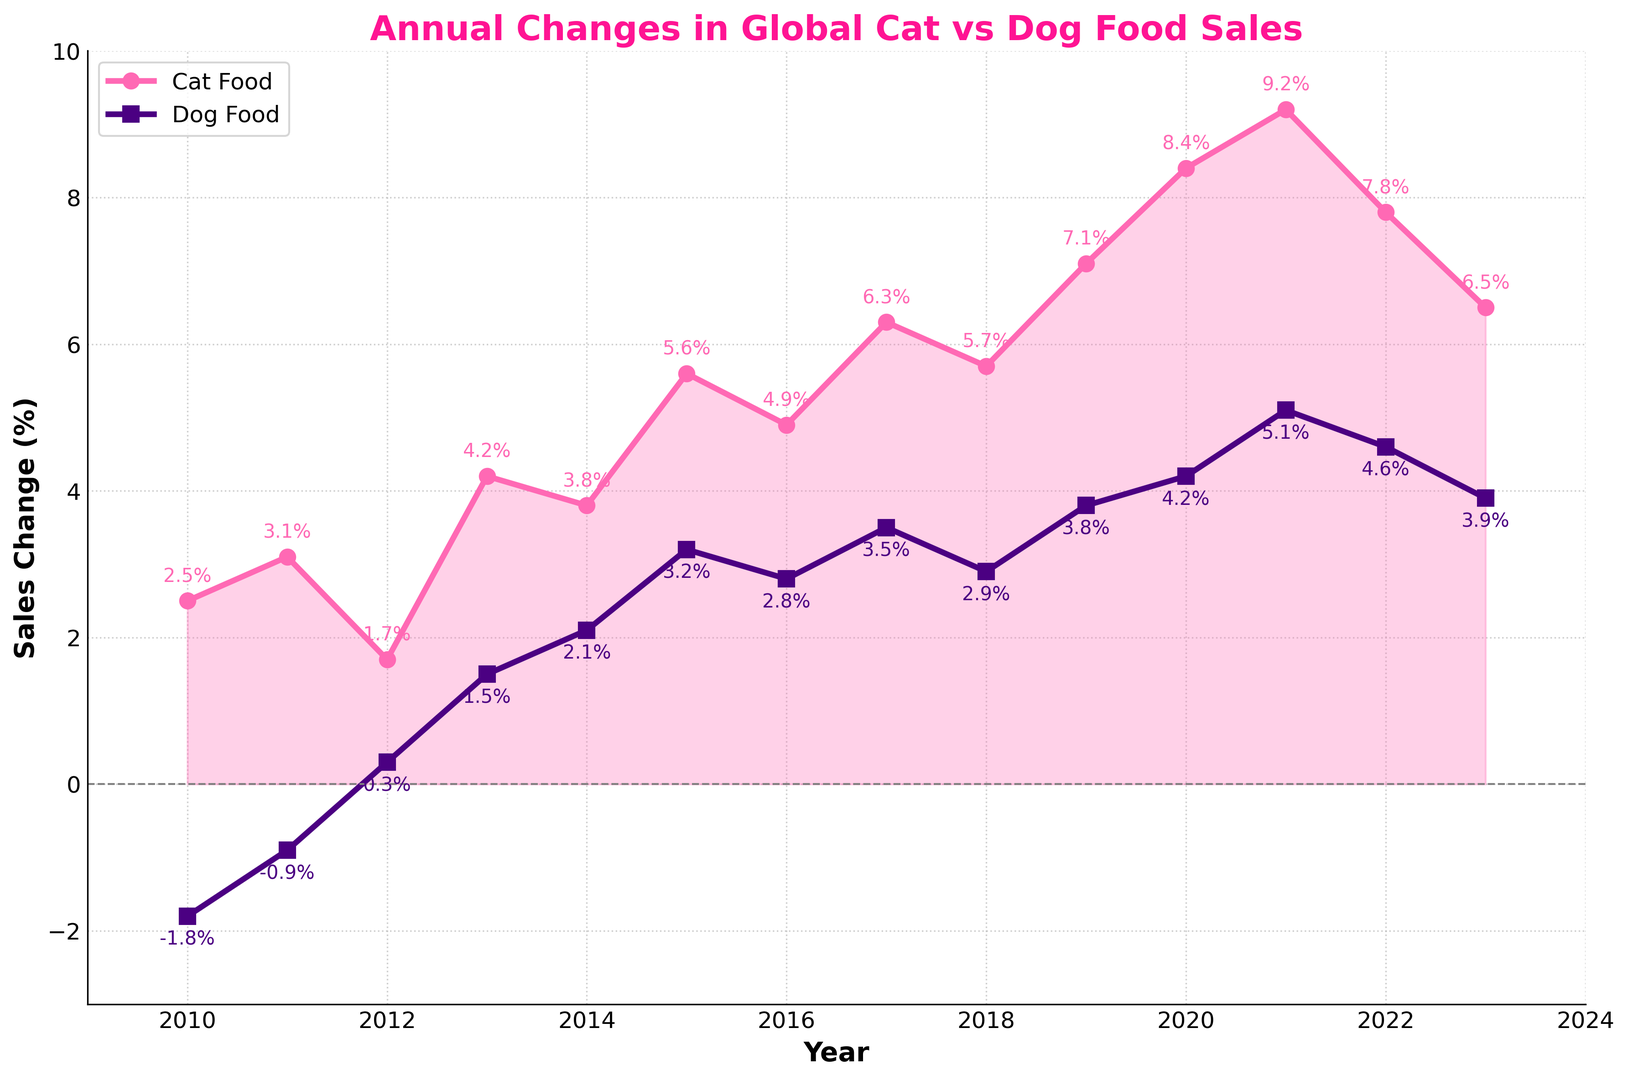Which year had the highest increase in cat food sales? By observing the line chart, we notice that the cat food line peaks at 9.2% in 2021.
Answer: 2021 How much did dog food sales change in 2011? The dog food sales change for 2011, represented by the square marker on the dog food line, is -0.9%.
Answer: -0.9% What is the difference in cat food sales between 2020 and 2023? The change in cat food sales in 2020 is 8.4% and in 2023 is 6.5%. Subtracting these gives 8.4% - 6.5% = 1.9%.
Answer: 1.9% In which years did cat food sales increase more than dog food sales? Cat food sales increased more than dog food sales in 2010, 2011, 2012, and from 2013 to 2023 as observed by the pink line being above the purple line.
Answer: 2010, 2011, 2012, 2013-2023 Which year had the smallest negative change in dog food sales? From the chart, the dog food line is negative only in 2010 and 2011. In 2011, the change is less negative at -0.9% compared to -1.8% in 2010.
Answer: 2011 What is the average annual change in cat food sales across all years? Sum the annual changes from 2010 to 2023 and divide by the number of years: (2.5 + 3.1 + 1.7 + 4.2 + 3.8 + 5.6 + 4.9 + 6.3 + 5.7 + 7.1 + 8.4 + 9.2 + 7.8 + 6.5)/14 ≈ 5.32%.
Answer: 5.32% During which years did the dog food sales experience positive change? Dog food sales were positive from 2012 to 2023 as the data points for these years are all above 0%.
Answer: 2012-2023 What was the trend in dog food sales from 2012 to 2021? From 2012 to 2021, the line representing dog food sales shows an increasing trend, going from 0.3% to 5.1%.
Answer: Increasing How many years did cat food sales change by more than 5%? By counting the years when cat food sales were above 5%: 2015, 2017, 2019, 2020, 2021, and 2022. This totals to 6 years.
Answer: 6 Was there any year when the change in cat food sales was below 2%? Cat food sales were below 2% in 2012, marked by a point at 1.7%.
Answer: 2012 